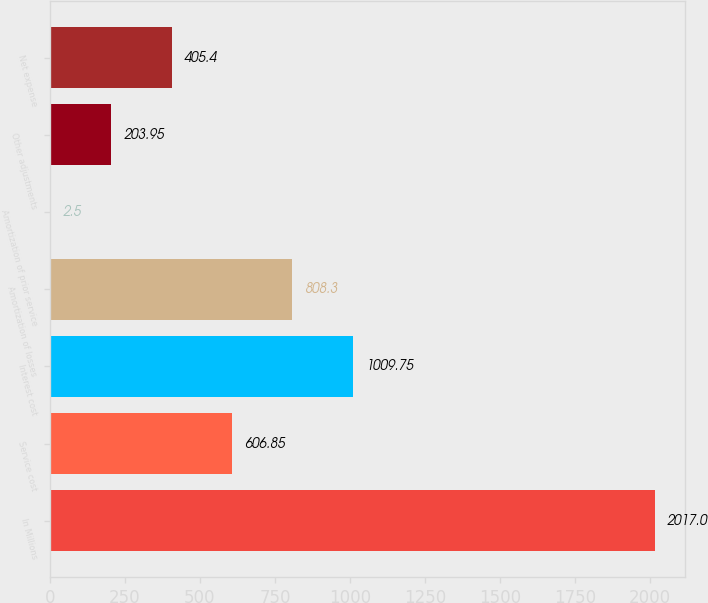Convert chart to OTSL. <chart><loc_0><loc_0><loc_500><loc_500><bar_chart><fcel>In Millions<fcel>Service cost<fcel>Interest cost<fcel>Amortization of losses<fcel>Amortization of prior service<fcel>Other adjustments<fcel>Net expense<nl><fcel>2017<fcel>606.85<fcel>1009.75<fcel>808.3<fcel>2.5<fcel>203.95<fcel>405.4<nl></chart> 